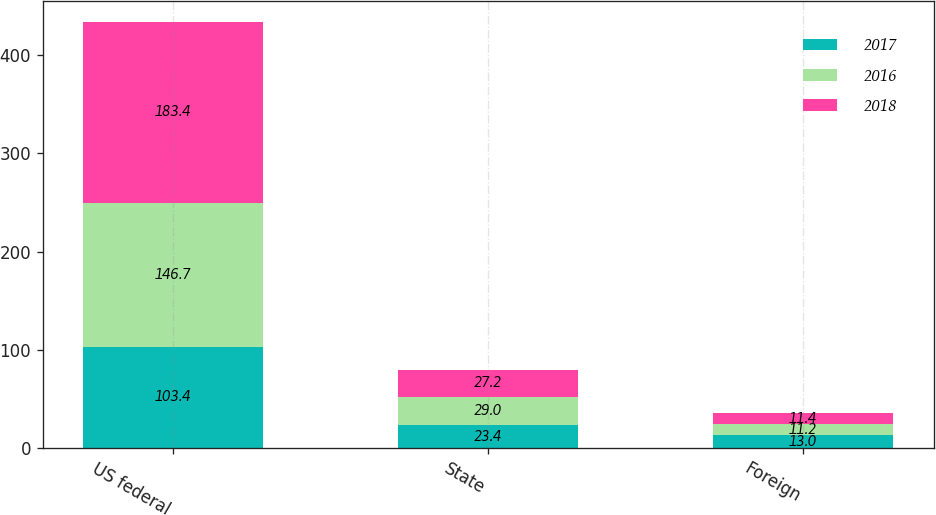Convert chart to OTSL. <chart><loc_0><loc_0><loc_500><loc_500><stacked_bar_chart><ecel><fcel>US federal<fcel>State<fcel>Foreign<nl><fcel>2017<fcel>103.4<fcel>23.4<fcel>13<nl><fcel>2016<fcel>146.7<fcel>29<fcel>11.2<nl><fcel>2018<fcel>183.4<fcel>27.2<fcel>11.4<nl></chart> 